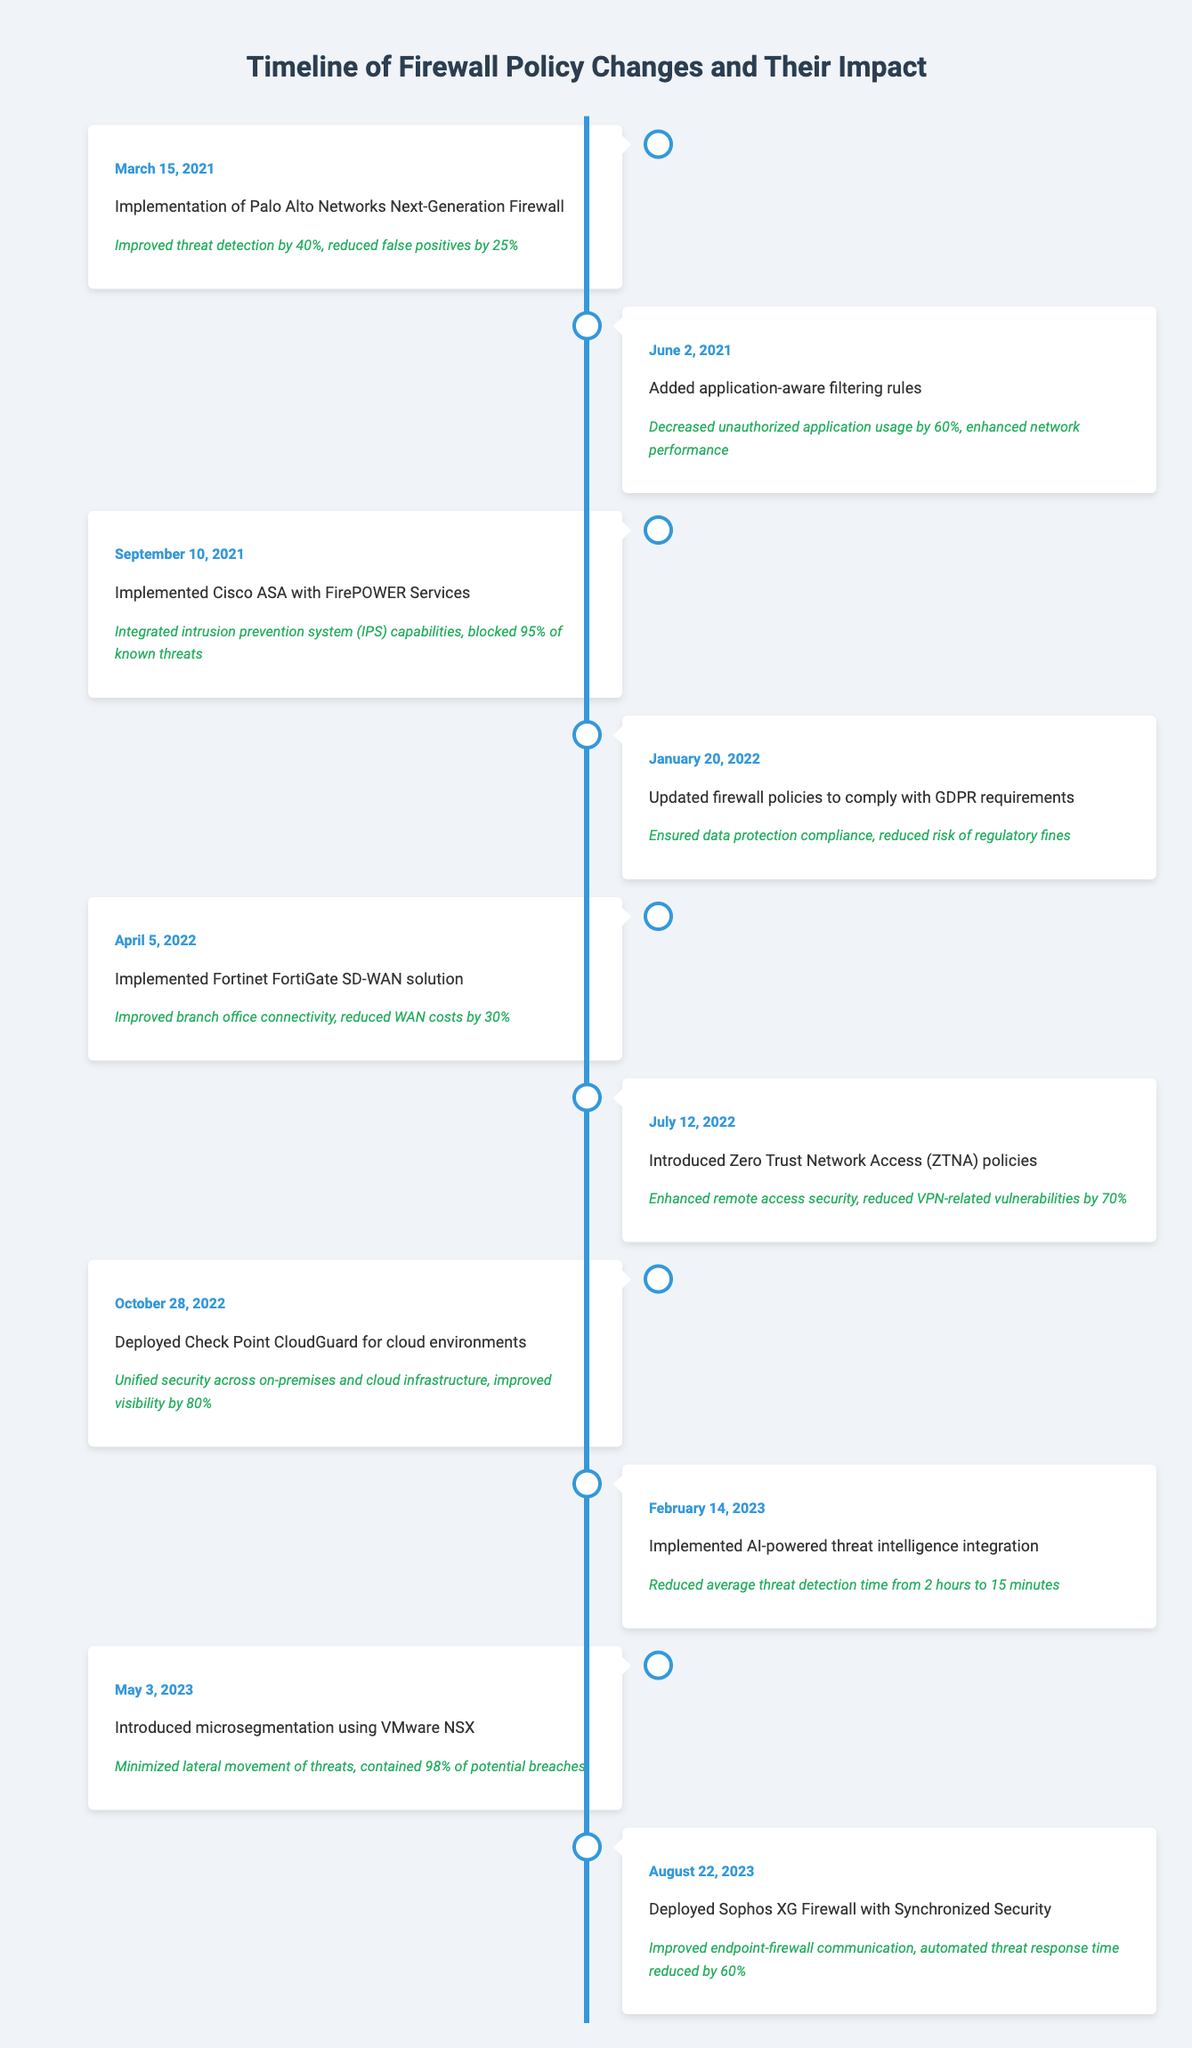What was the impact of the firewall policy changes implemented on March 15, 2021? The event on March 15, 2021, was the implementation of Palo Alto Networks Next-Generation Firewall, which led to improved threat detection by 40% and a reduction in false positives by 25%.
Answer: Improved threat detection by 40%, reduced false positives by 25% What percentage of unauthorized application usage was decreased after the event on June 2, 2021? The event on June 2, 2021, focused on adding application-aware filtering rules, which resulted in a decrease of unauthorized application usage by 60%.
Answer: 60% Did the implementation of Zero Trust Network Access policies reduce VPN-related vulnerabilities? The introduction of Zero Trust Network Access policies on July 12, 2022, did indeed reduce VPN-related vulnerabilities by 70%, confirming that this change positively impacted security.
Answer: Yes Which event had the greatest impact on threat detection time? The implementation of AI-powered threat intelligence on February 14, 2023, significantly improved threat detection time, reducing it from 2 hours to just 15 minutes, which is the greatest impact on detection time among all listed events.
Answer: AI-powered threat intelligence integration How much was the reduction in WAN costs after the implementation of the Fortinet FortiGate SD-WAN solution? The implementation of the Fortinet FortiGate SD-WAN solution on April 5, 2022, resulted in a reduction of WAN costs by 30%, as documented in the event's impact.
Answer: 30% What was the average percentage improvement in visibility achieved through the security changes listed? There are two instances reporting visibility improvements: Check Point CloudGuard improved visibility by 80%, and AI-powered threat intelligence integration led to a time reduction in threat detection but does not specify visibility. Thus, calculating the average based solely on the one clear event results in 80%.
Answer: 80% Which implementation resulted in the containment of 98% of potential breaches? The introduction of microsegmentation using VMware NSX on May 3, 2023, was specifically responsible for containing 98% of potential breaches, as highlighted in that event.
Answer: VMware NSX microsegmentation Was there any event that specifically addressed GDPR compliance? Yes, on January 20, 2022, there was an update of firewall policies to comply with GDPR requirements, which ensured data protection compliance and reduced the risk of regulatory fines.
Answer: Yes What event occurred after the implementation of Cisco ASA with FirePOWER Services? The next event after the implementation of Cisco ASA with FirePOWER Services on September 10, 2021, was the update of firewall policies to comply with GDPR requirements on January 20, 2022.
Answer: GDPR policy update Which event achieved automated threat response time reduction? The deployment of Sophos XG Firewall with Synchronized Security on August 22, 2023, achieved a reduction in automated threat response time by 60%.
Answer: Sophos XG Firewall deployment 